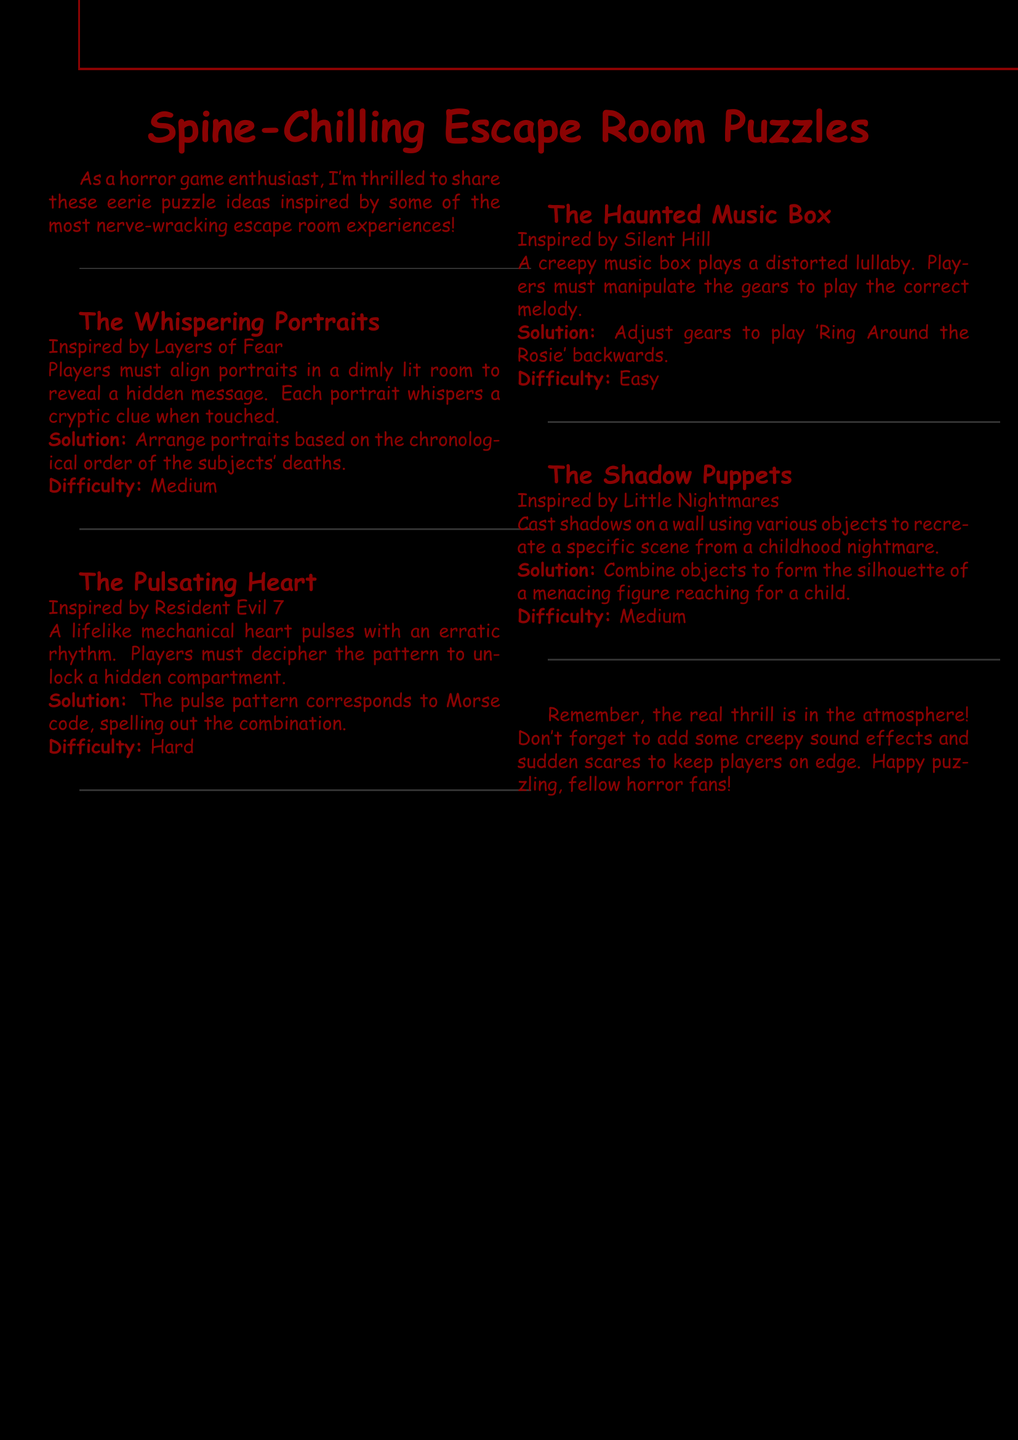What is the title of the document? The title is provided at the beginning of the document and highlights the theme of the puzzles.
Answer: Spine-Chilling Escape Room Puzzles How many puzzles are listed? The document lists a total of four distinct puzzles, each with its own details.
Answer: 4 What inspired "The Whispering Portraits"? This information is found under the description of the puzzle, linking it to its source of inspiration.
Answer: Layers of Fear What is the difficulty rating for "The Pulsating Heart"? This detail specifies how challenging the puzzle is considered within the collection.
Answer: Hard What melody must be played in "The Haunted Music Box"? This is the specific song referenced in the solution of the puzzle, providing clarity on the objective.
Answer: Ring Around the Rosie What type of objects are used in "The Shadow Puppets"? The types of objects are crucial for understanding how the puzzle is solved and what materials are involved.
Answer: Various objects What must players do in "The Whispering Portraits"? This describes the primary action players need to complete for this puzzle in the document.
Answer: Align portraits What is the key element to enhance the escape room experience mentioned in the conclusion? The conclusion emphasizes an important aspect that affects player immersion in the game.
Answer: Creepy sound effects 